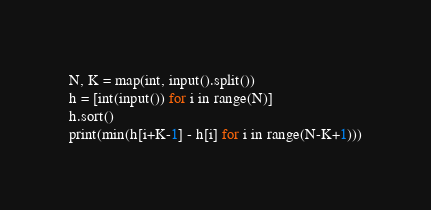<code> <loc_0><loc_0><loc_500><loc_500><_Python_>N, K = map(int, input().split())
h = [int(input()) for i in range(N)]
h.sort()
print(min(h[i+K-1] - h[i] for i in range(N-K+1)))</code> 